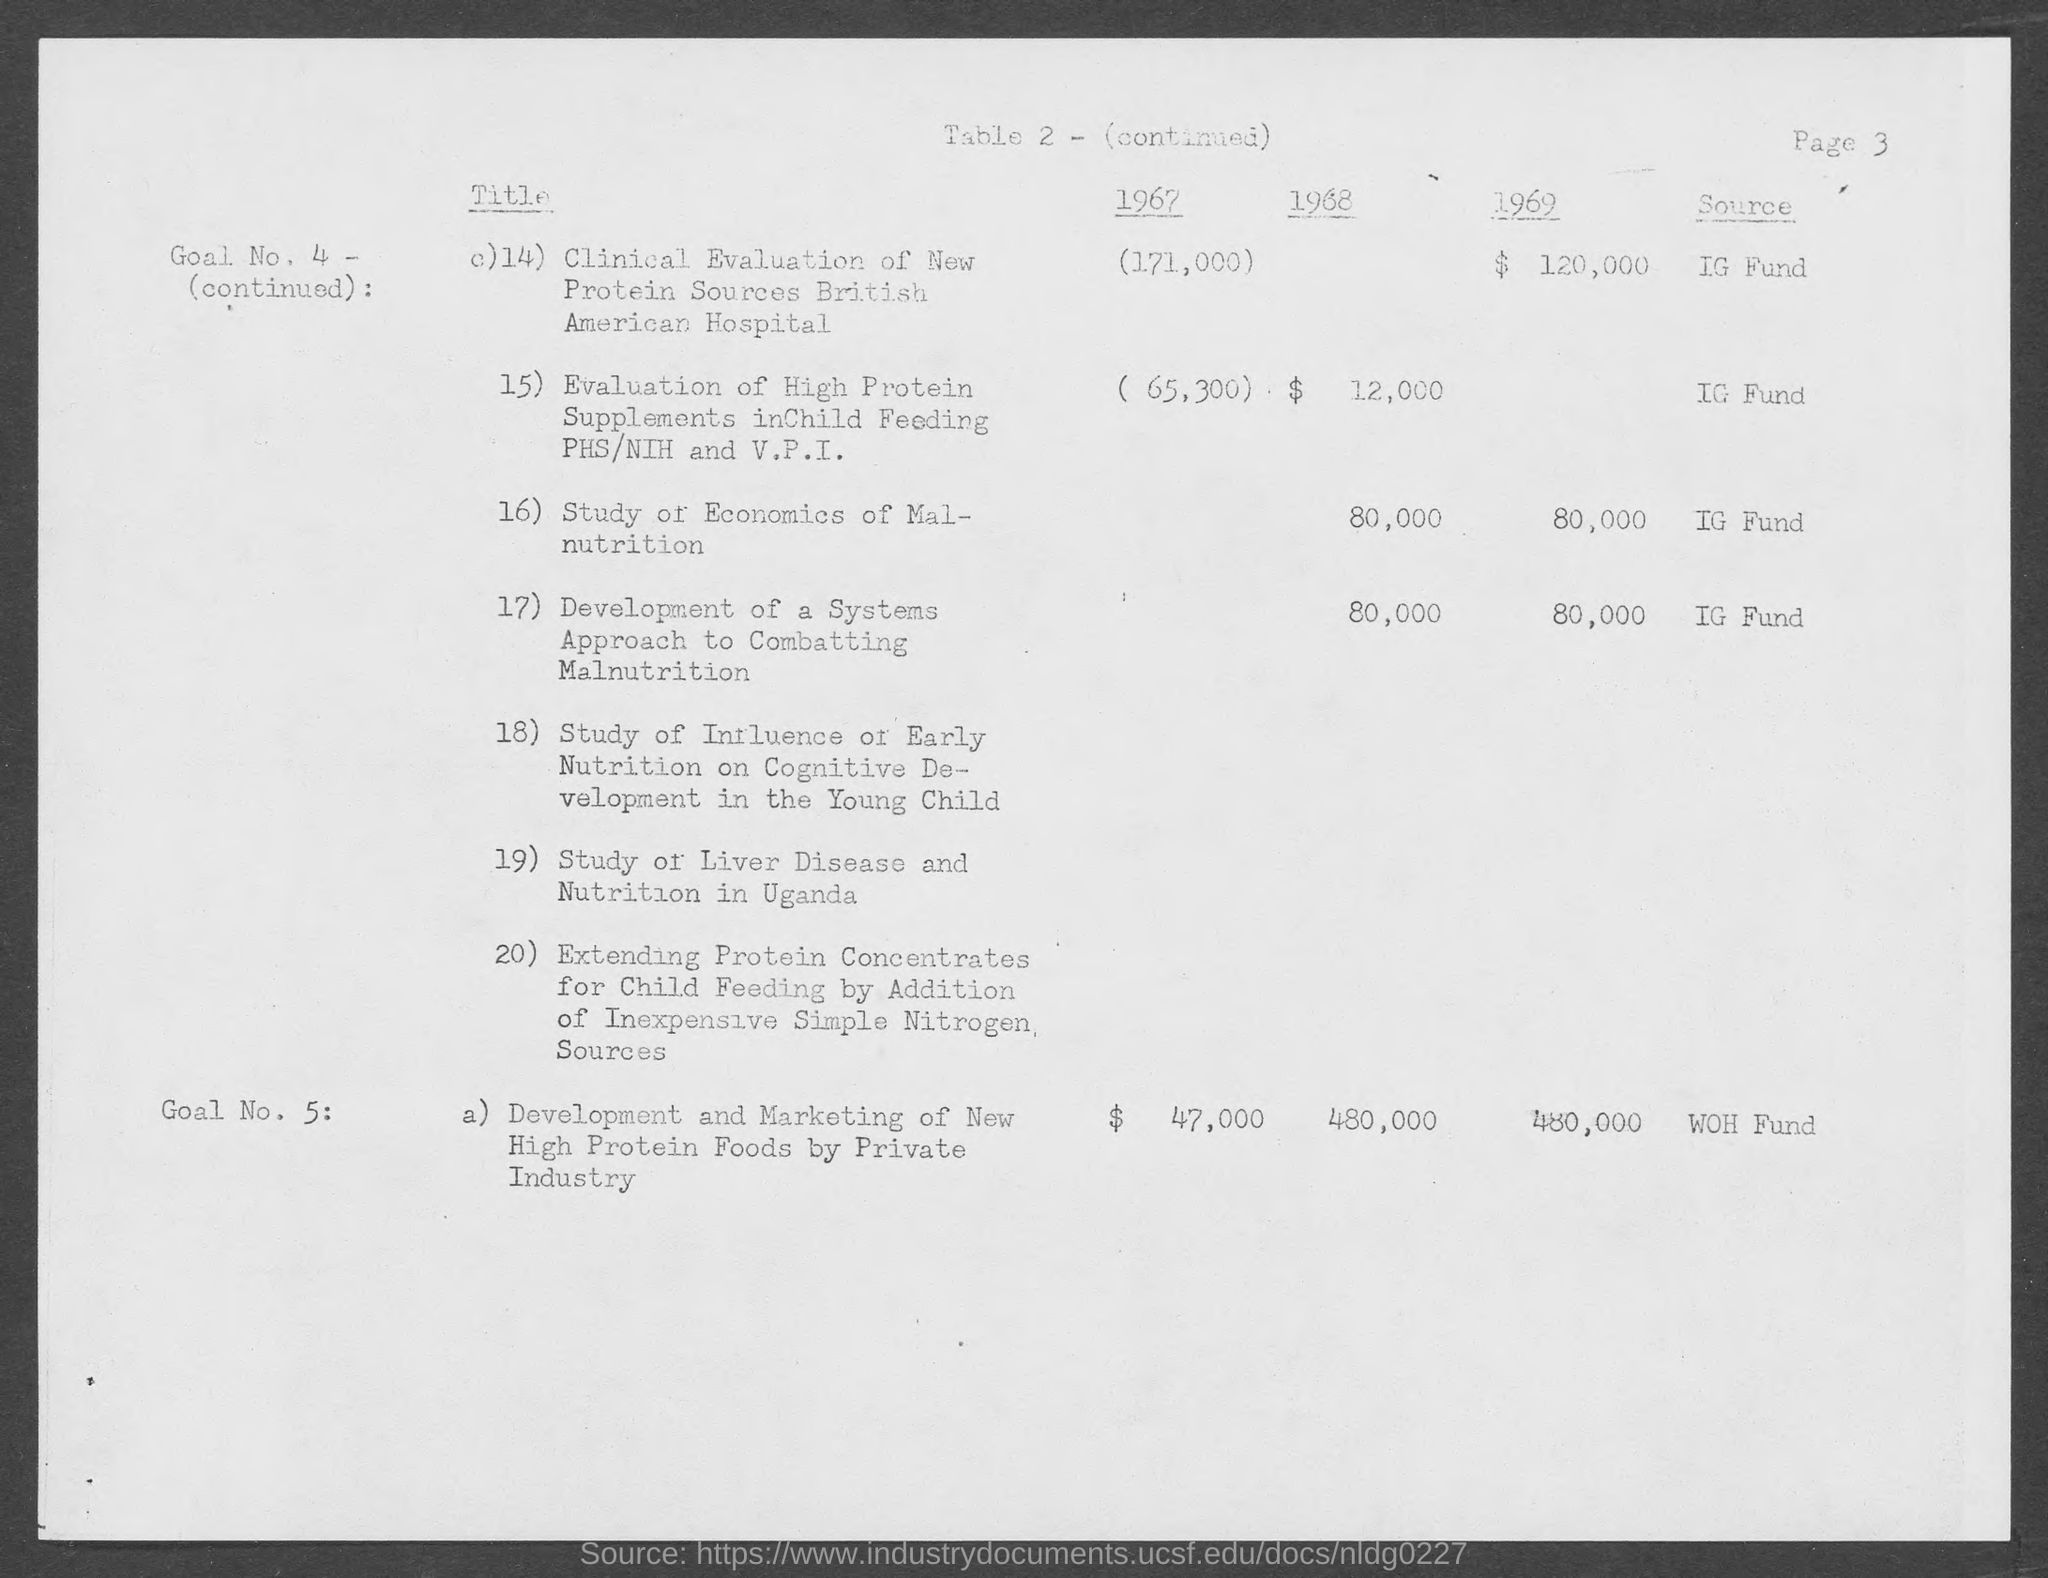Specify some key components in this picture. The funding source for the development and marketing of new high protein foods by private industry is typically through a private or corporate investment group known as WOH Fund. In the year 1969, the cost for a clinical evaluation of new protein sources at the British American Hospital was $120,000. The source of fund for the study of the economics of malnutrition is the IG Fund. In the year 1967, private industry incurred a cost of approximately $47,000 in the development and marketing of new high protein foods. The funding source for the clinical evaluation of new protein sources at British American Hospital is the IG Fund. 